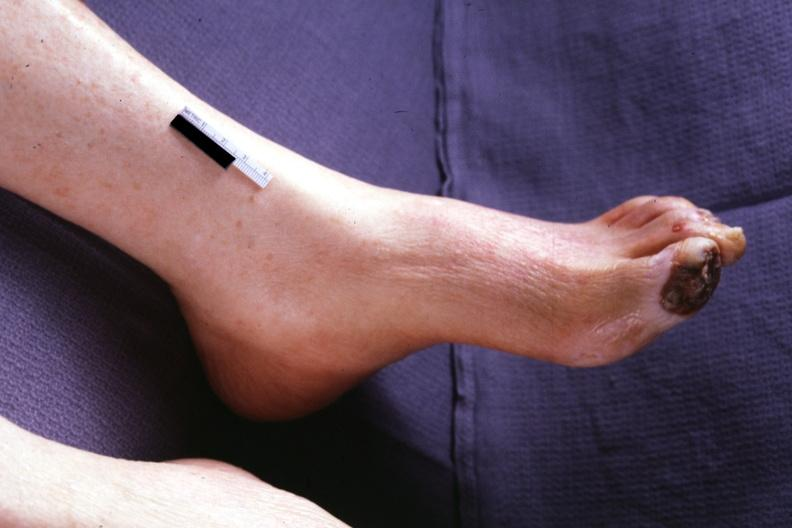s chest and abdomen slide present?
Answer the question using a single word or phrase. No 